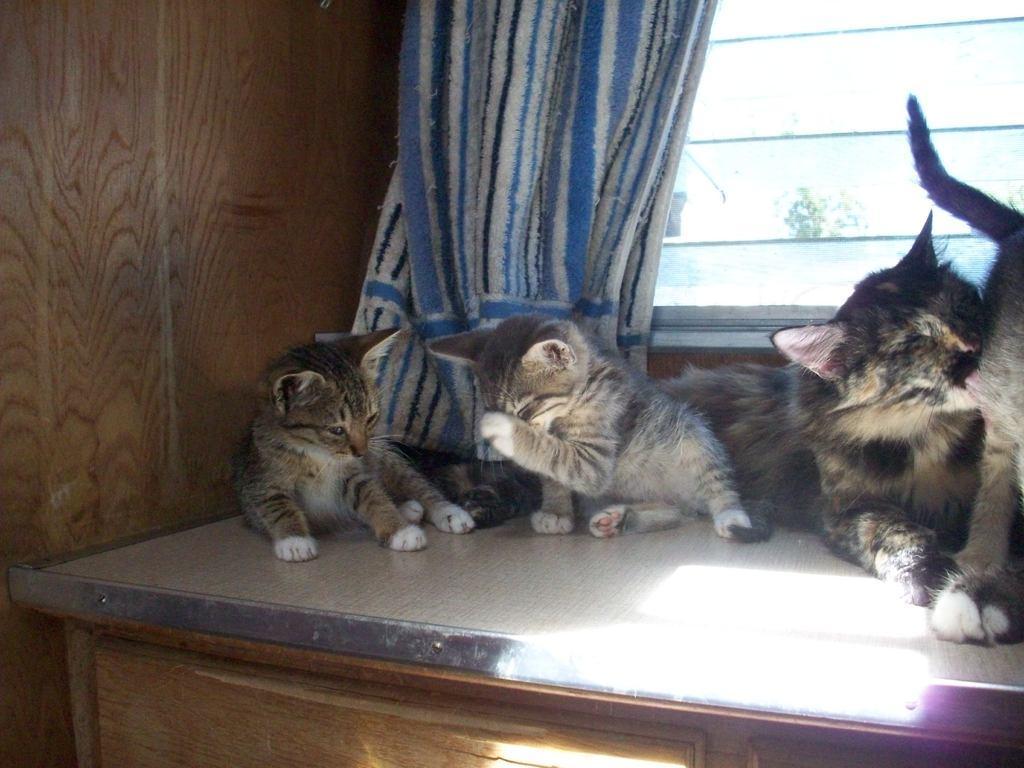In one or two sentences, can you explain what this image depicts? In this image, there are cats on a wooden object. In the background, I can see a curtain, window and a wooden wall. 